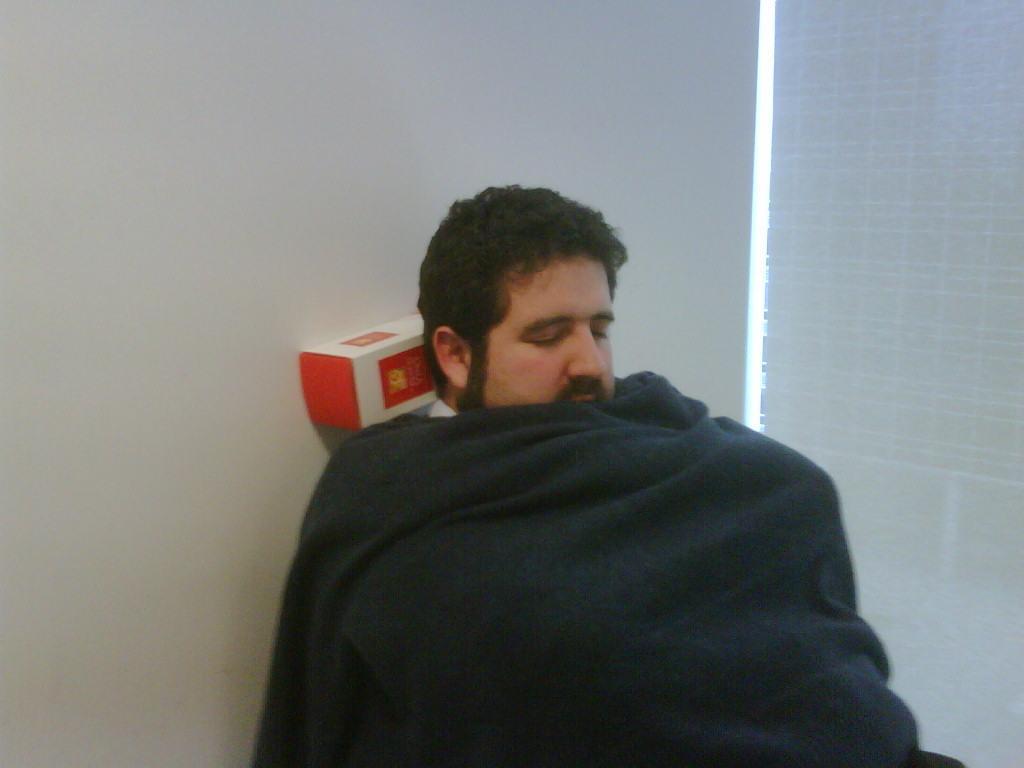Describe this image in one or two sentences. In this image there is one person who is sleeping, and there is a blanket and some box and in the background there is wall window and blinds. 